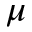Convert formula to latex. <formula><loc_0><loc_0><loc_500><loc_500>\mu</formula> 